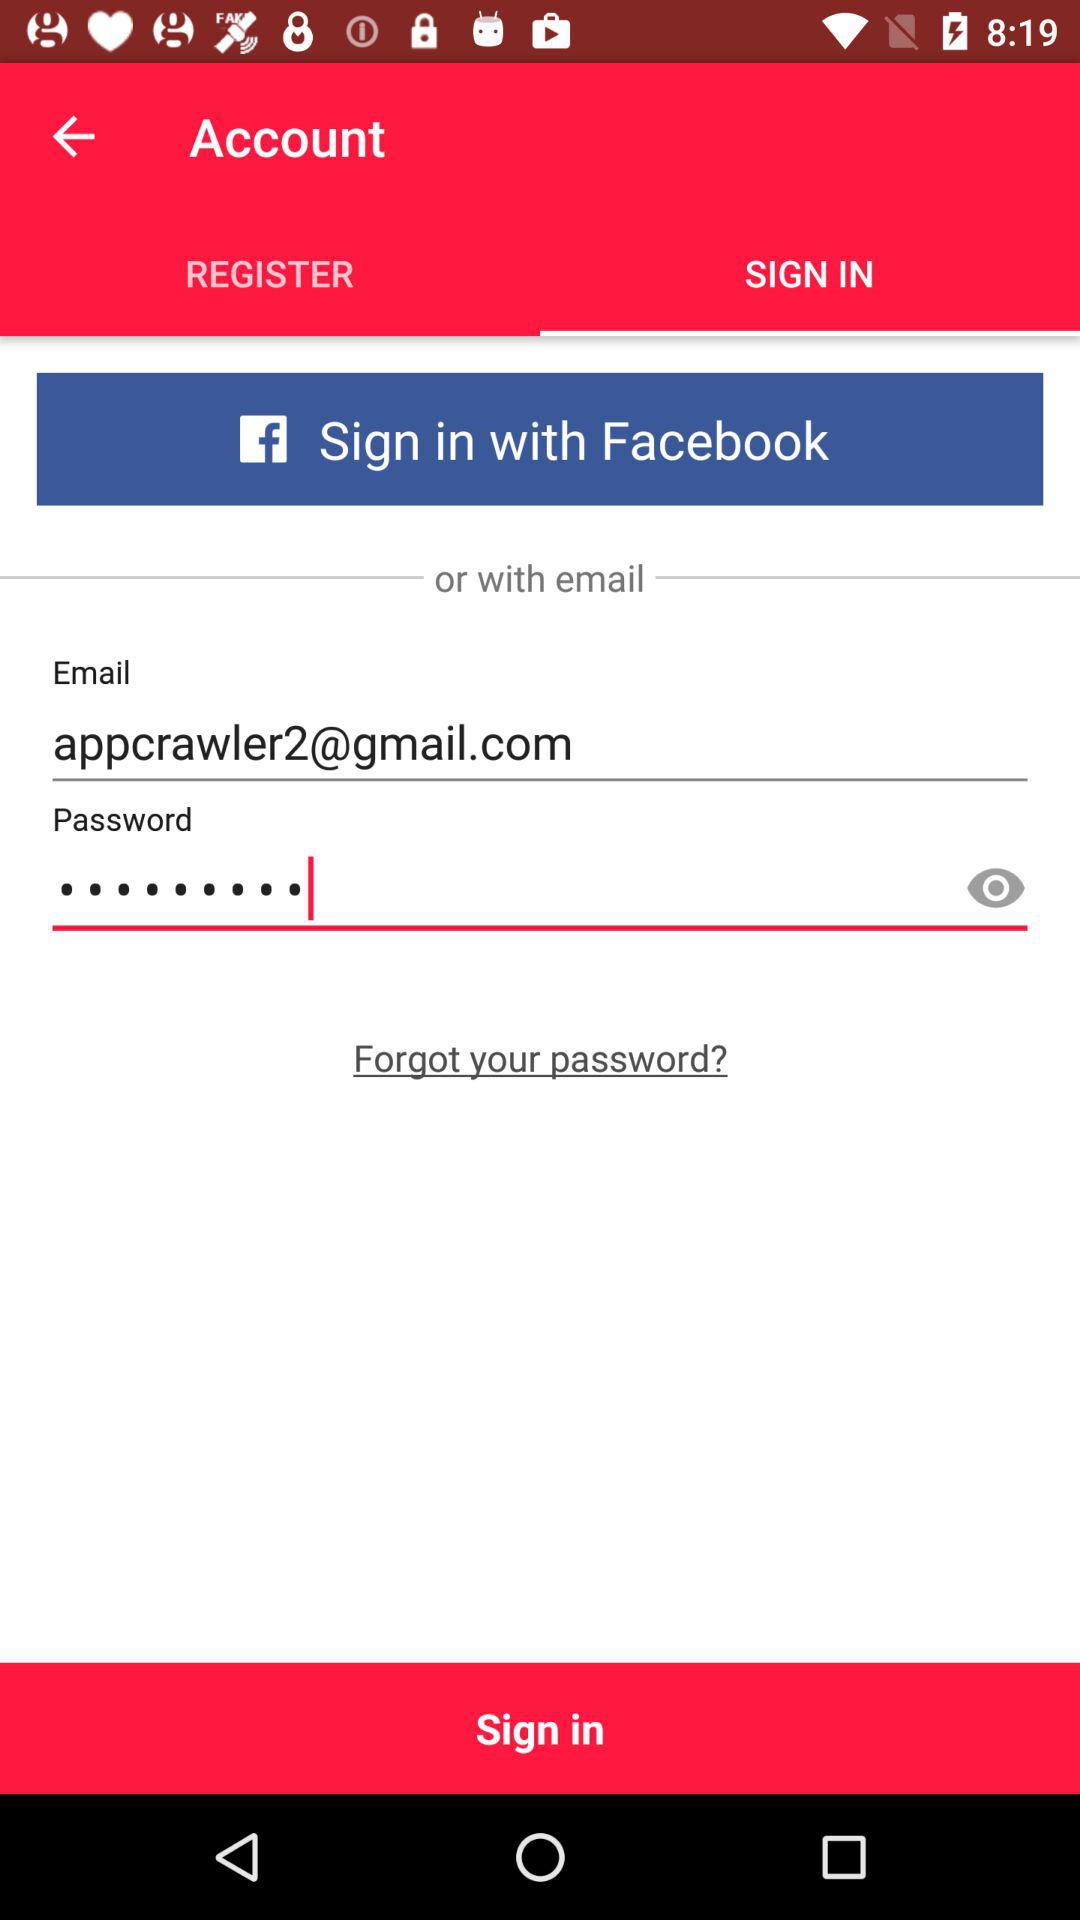What is the email address? The email address is appcrawler2@gmail.com. 